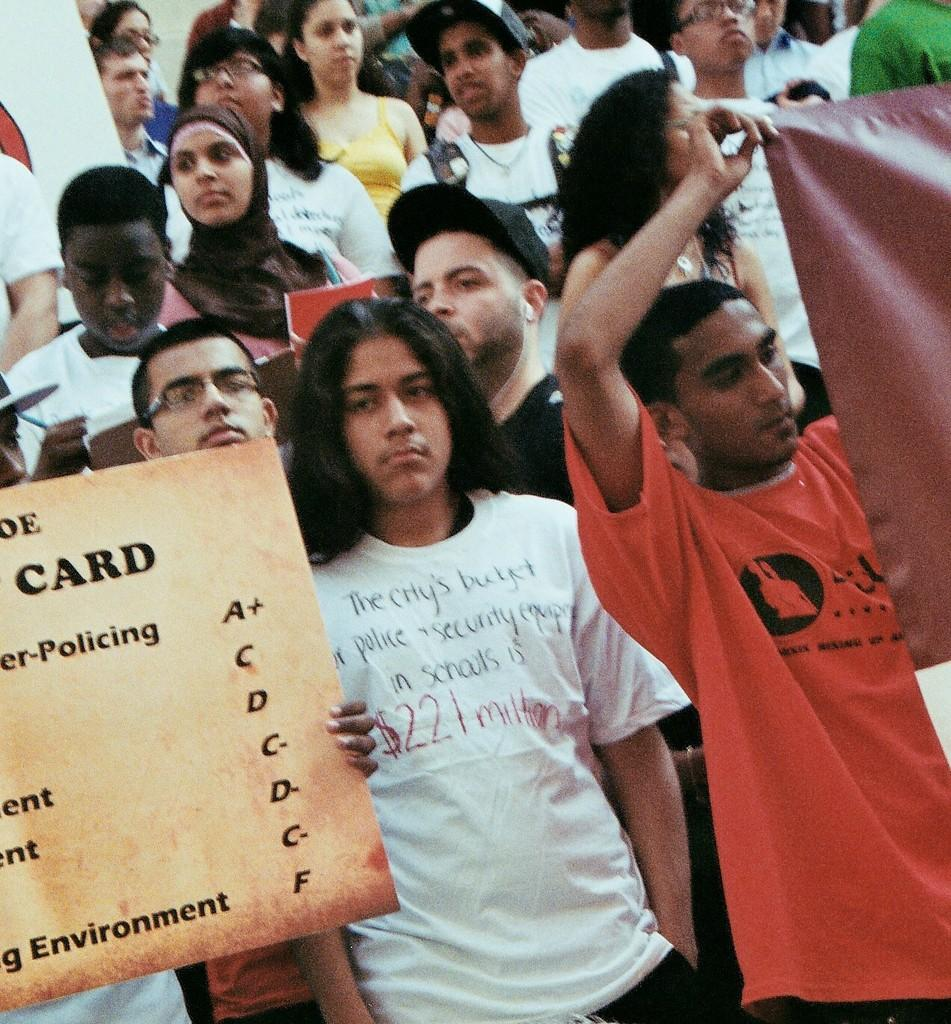What is the main subject of the image? The main subject of the image is a group of people. What are the people in the image doing? The people are standing in the image. Are any of the people holding anything? Yes, some people are holding objects. What type of page can be seen in the image? There is no page present in the image. How many balls are visible in the image? There are no balls visible in the image. 